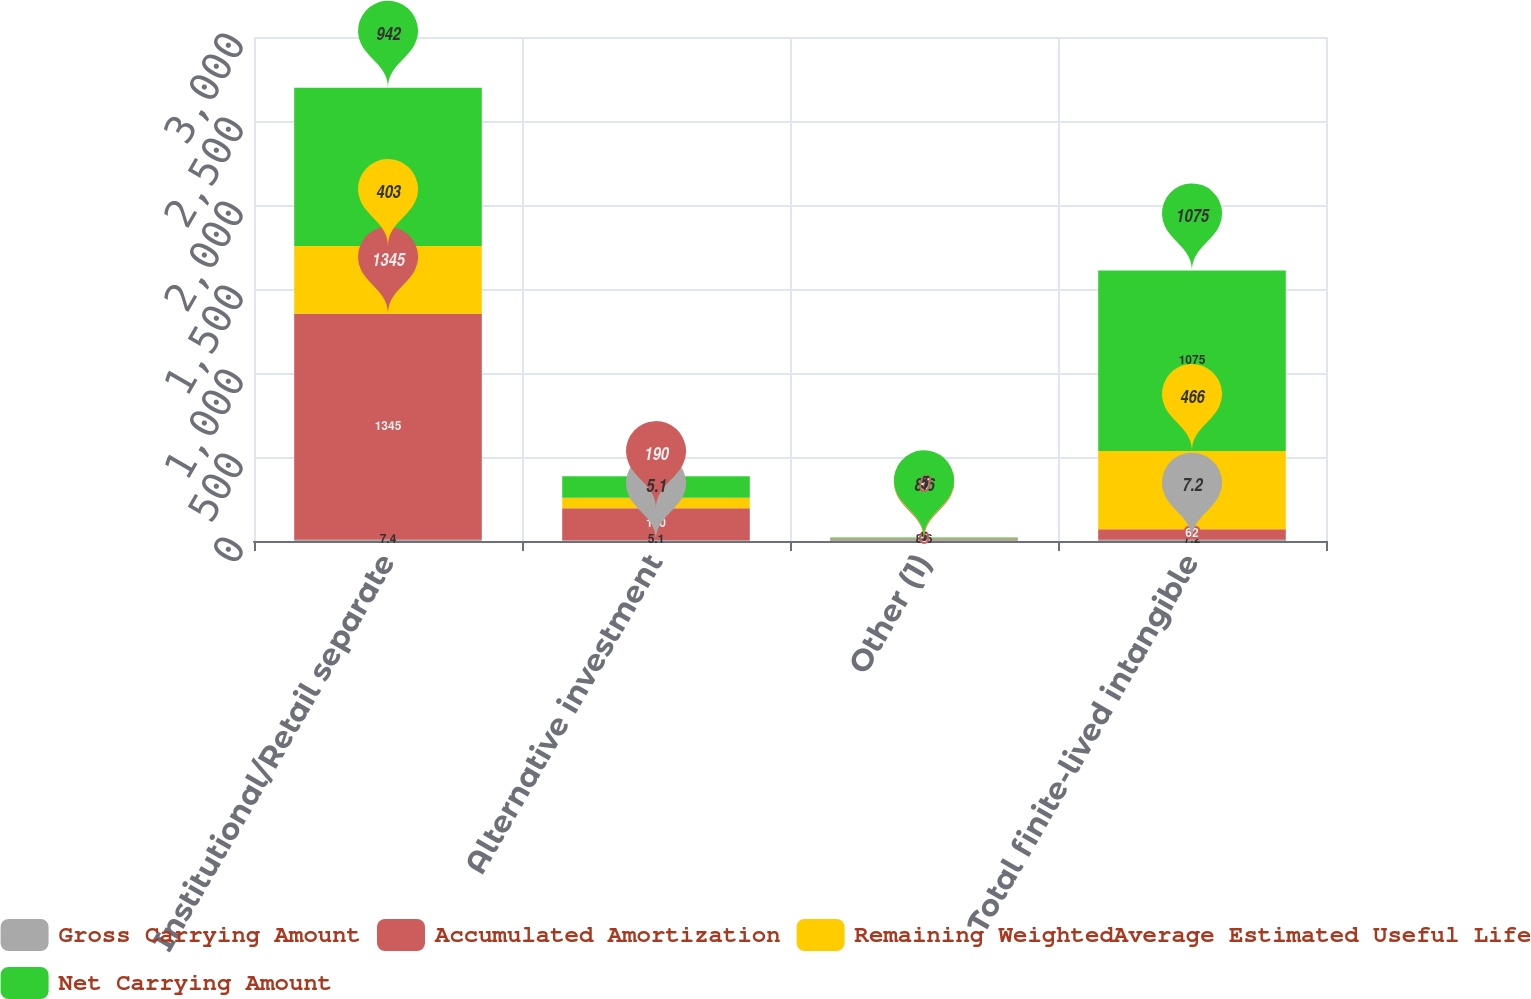Convert chart to OTSL. <chart><loc_0><loc_0><loc_500><loc_500><stacked_bar_chart><ecel><fcel>Institutional/Retail separate<fcel>Alternative investment<fcel>Other (1)<fcel>Total finite-lived intangible<nl><fcel>Gross Carrying Amount<fcel>7.4<fcel>5.1<fcel>8.6<fcel>7.2<nl><fcel>Accumulated Amortization<fcel>1345<fcel>190<fcel>6<fcel>62<nl><fcel>Remaining WeightedAverage Estimated Useful Life<fcel>403<fcel>62<fcel>1<fcel>466<nl><fcel>Net Carrying Amount<fcel>942<fcel>128<fcel>5<fcel>1075<nl></chart> 